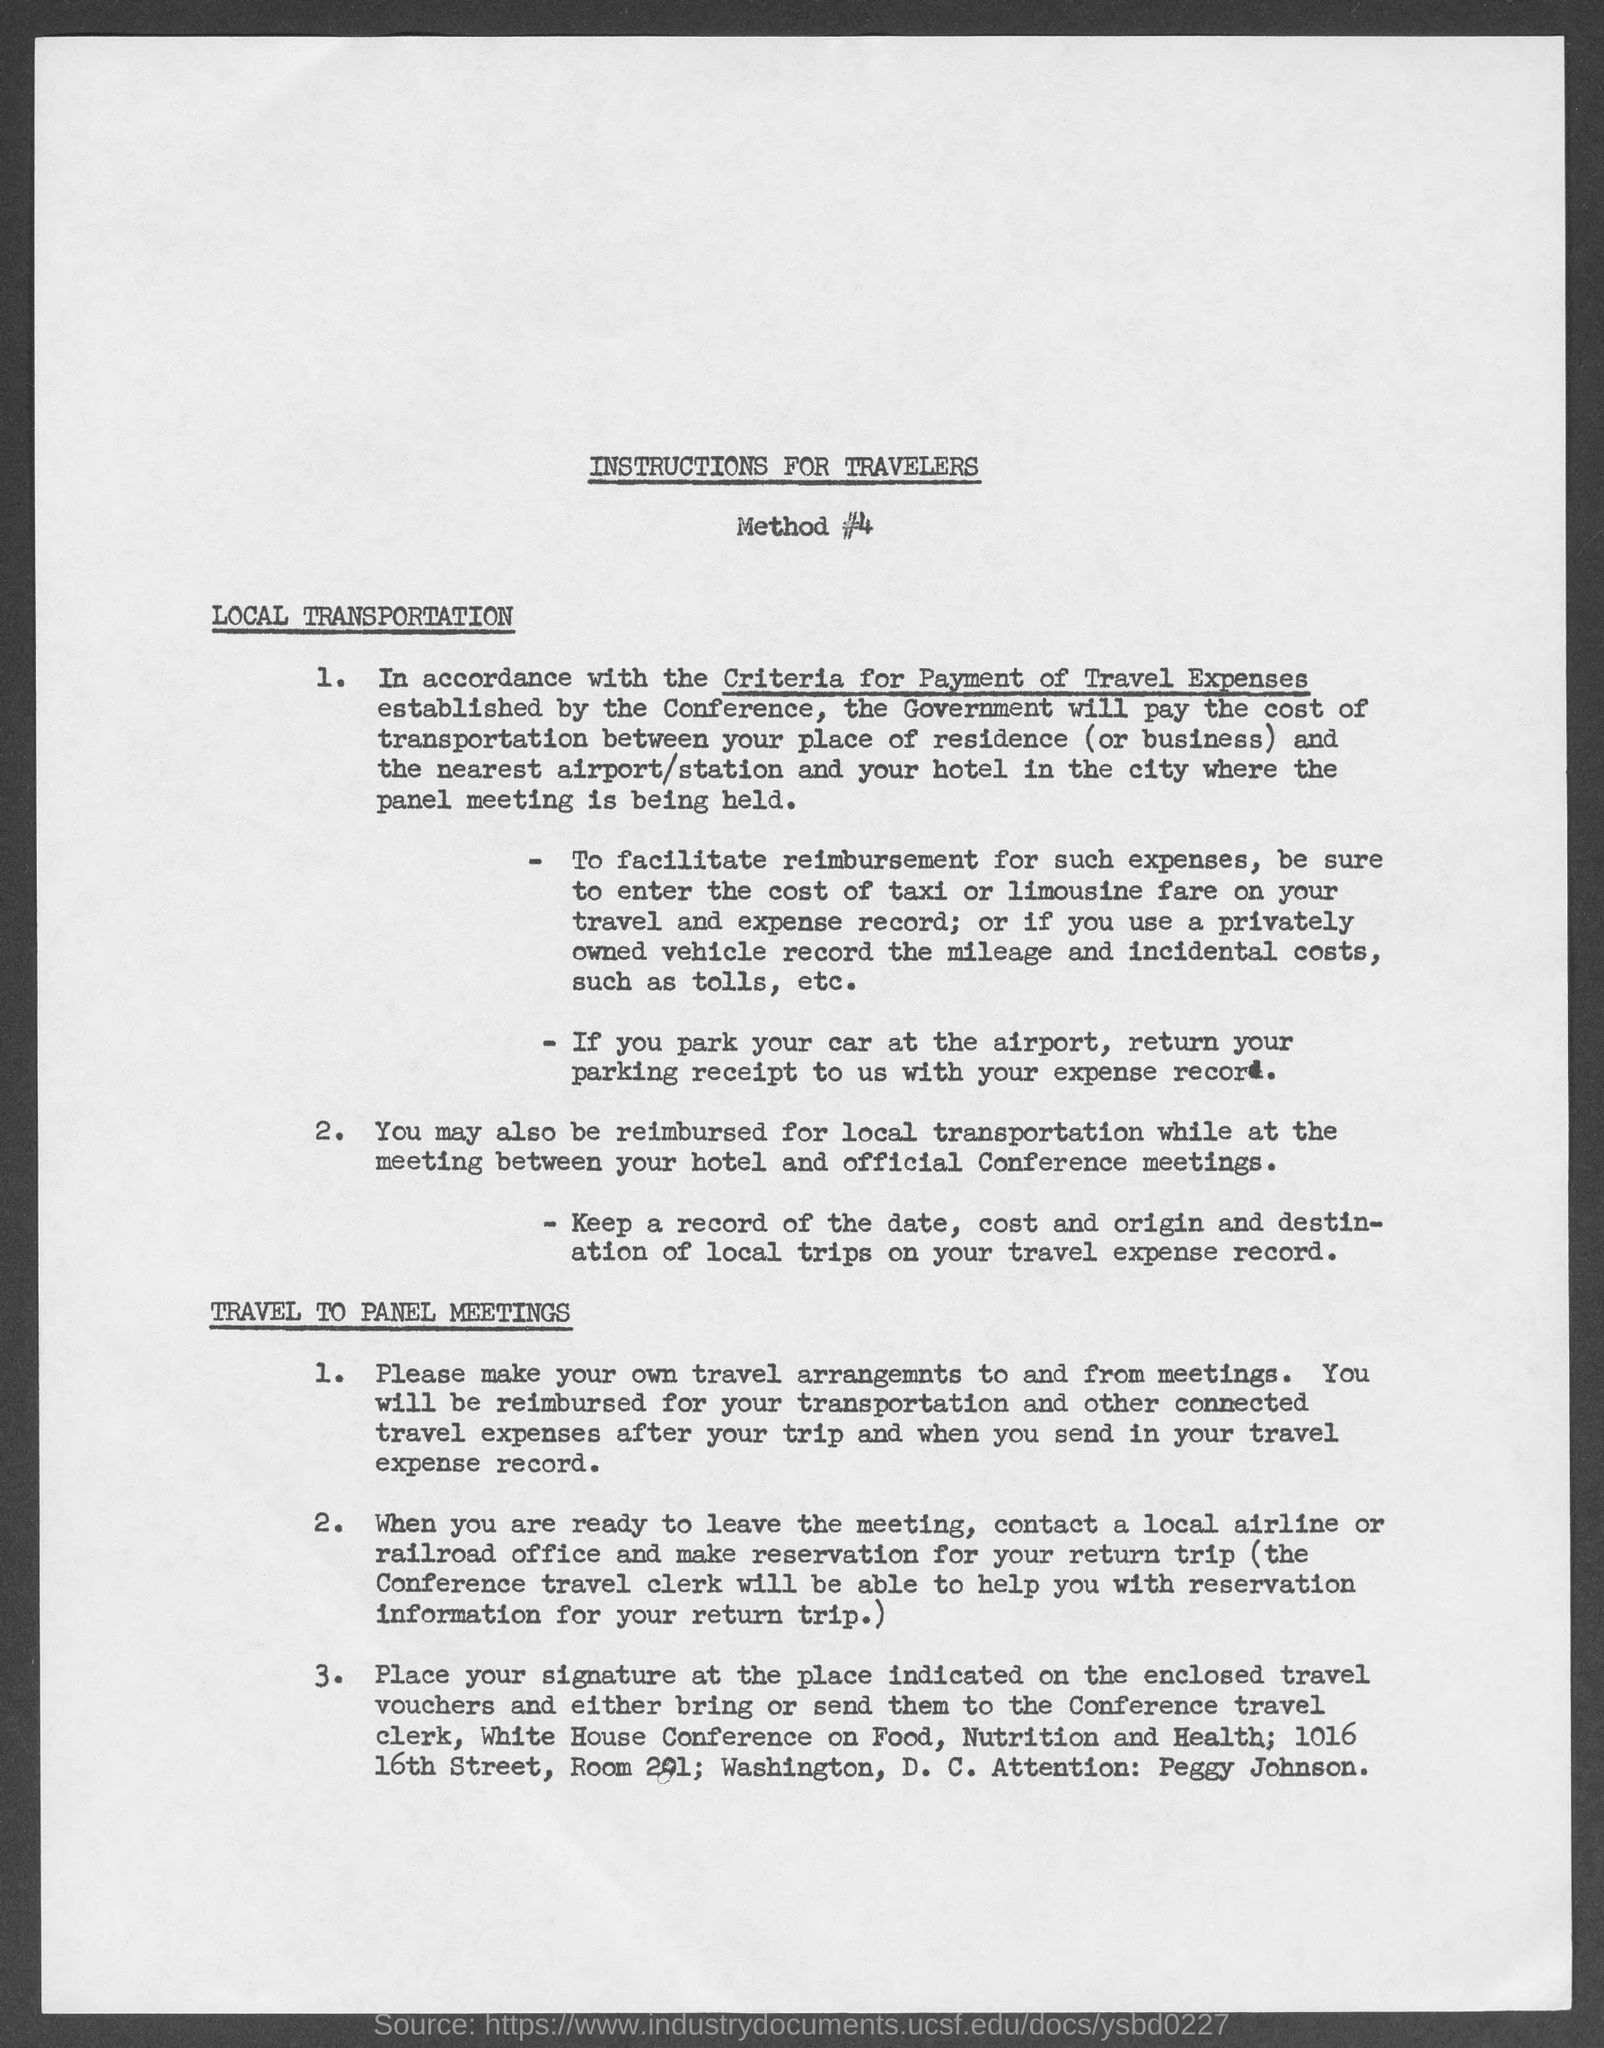Mention a couple of crucial points in this snapshot. The government will be responsible for paying the cost of transportation. It is necessary to record the mileage and incidental costs, such as tolls, when privately owned vehicles are used. The placement of the signature is to occur at the designated location on the enclosed travel vouchers. 